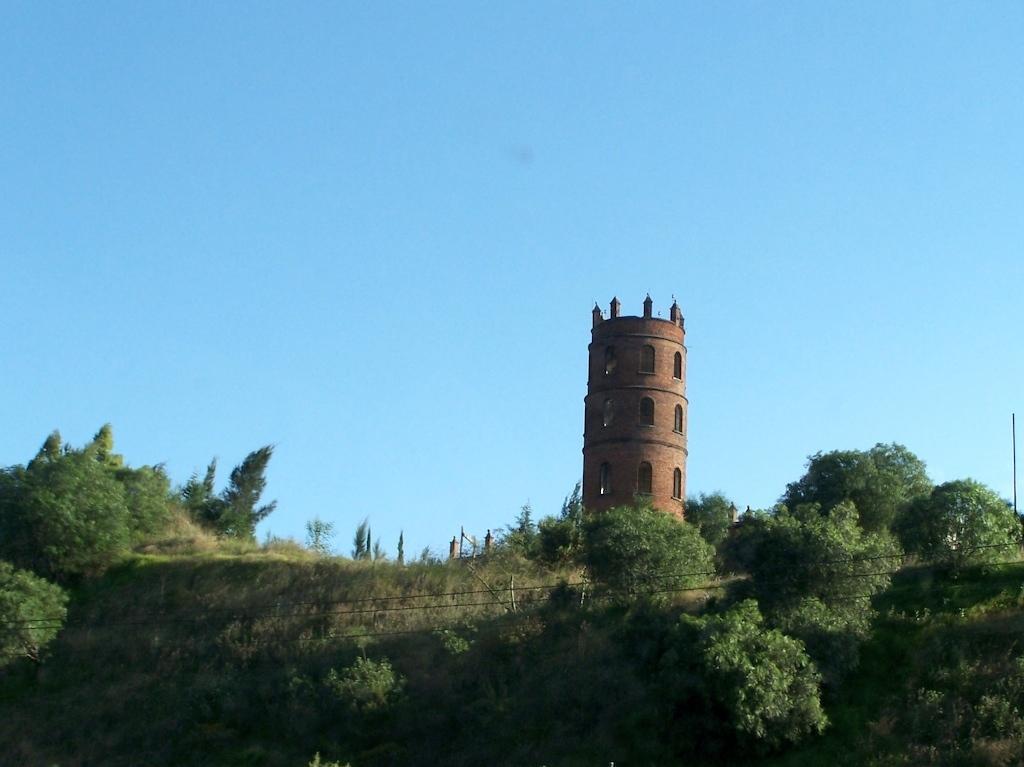Describe this image in one or two sentences. In this image we can see grass, wires, a group of trees and a tower. At the top we can see the sky. 